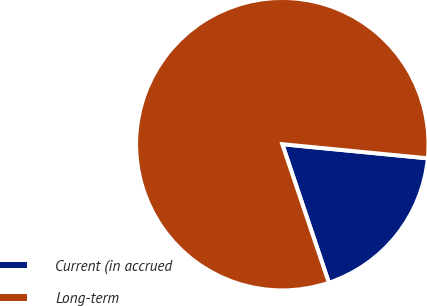<chart> <loc_0><loc_0><loc_500><loc_500><pie_chart><fcel>Current (in accrued<fcel>Long-term<nl><fcel>18.3%<fcel>81.7%<nl></chart> 